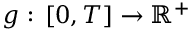<formula> <loc_0><loc_0><loc_500><loc_500>g \colon \, [ 0 , T ] \to \mathbb { R } ^ { + }</formula> 